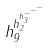Convert formula to latex. <formula><loc_0><loc_0><loc_500><loc_500>h _ { 9 } ^ { h _ { 2 } ^ { h _ { 3 } ^ { - ^ { - ^ { - } } } } }</formula> 